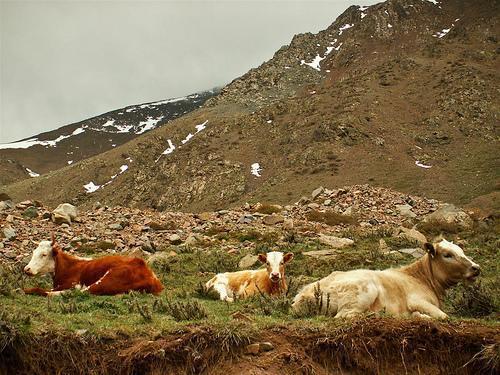How many cows are standing?
Give a very brief answer. 0. How many cows can you see?
Give a very brief answer. 3. How many bikes are on the fence?
Give a very brief answer. 0. 